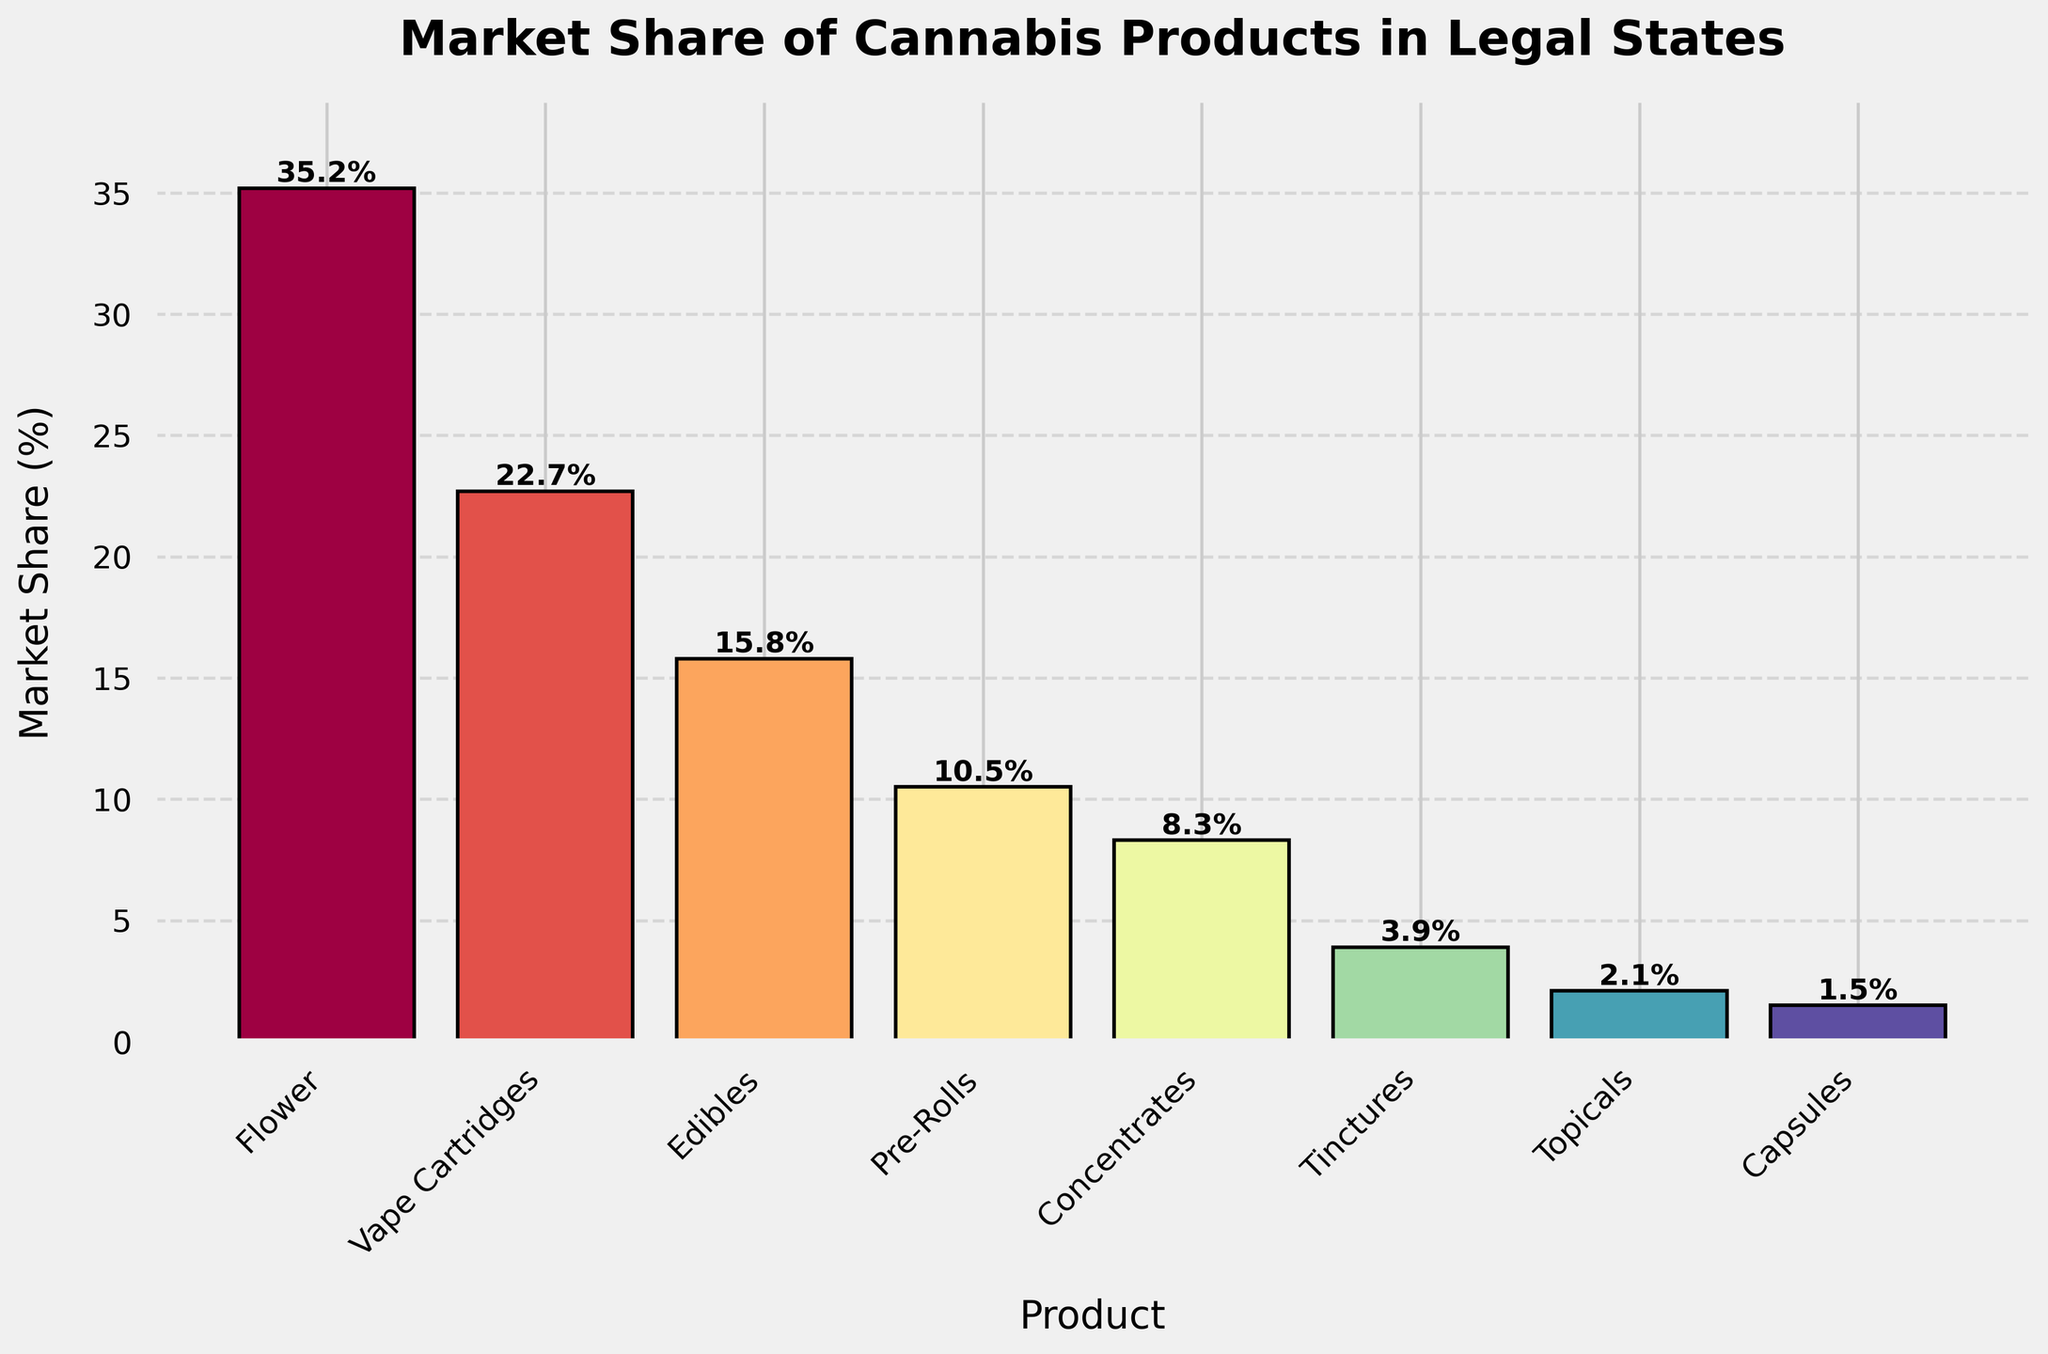Which cannabis product has the highest market share? By visually examining the heights of the bars, it is clear that the 'Flower' product has the tallest bar, indicating the highest market share.
Answer: Flower What's the combined market share of Edibles and Pre-Rolls? Find the market share value for Edibles (15.8%) and Pre-Rolls (10.5%) and add them together: 15.8 + 10.5 = 26.3%.
Answer: 26.3% How much more market share does Flower have compared to Capsules? Subtract the market share of Capsules (1.5%) from that of Flower (35.2%): 35.2 - 1.5 = 33.7%.
Answer: 33.7% Which product has the lowest market share, and what is it? By identifying the shortest bar, Capsules have the lowest market share, which is 1.5%.
Answer: Capsules, 1.5% Are Vape Cartridges more popular than Edibles? Compare the heights of the Vape Cartridges and Edibles bars; Vape Cartridges (22.7%) are higher than Edibles (15.8%).
Answer: Yes What's the total market share of the top three products? Add the market share percentages of Flower (35.2%), Vape Cartridges (22.7%), and Edibles (15.8%): 35.2 + 22.7 + 15.8 = 73.7%.
Answer: 73.7% How does the market share of Concentrates compare to Tinctures? Compare the market share of Concentrates (8.3%) to Tinctures (3.9%); Concentrates have a higher market share than Tinctures.
Answer: Concentrates have a higher market share Which product has nearly half the market share of Flower? Identify the product whose market share is close to half of 35.2%. Pre-Rolls have a market share of 10.5%, which is close to half of Flower's share.
Answer: Pre-Rolls Arrange the products in descending order of their market share. List the products from the tallest to shortest bar: Flower, Vape Cartridges, Edibles, Pre-Rolls, Concentrates, Tinctures, Topicals, Capsules.
Answer: Flower, Vape Cartridges, Edibles, Pre-Rolls, Concentrates, Tinctures, Topicals, Capsules What is the difference in market share between the most popular and least popular products? Subtract the market share of Capsules (1.5%) from that of Flower (35.2%): 35.2 - 1.5 = 33.7%.
Answer: 33.7% 